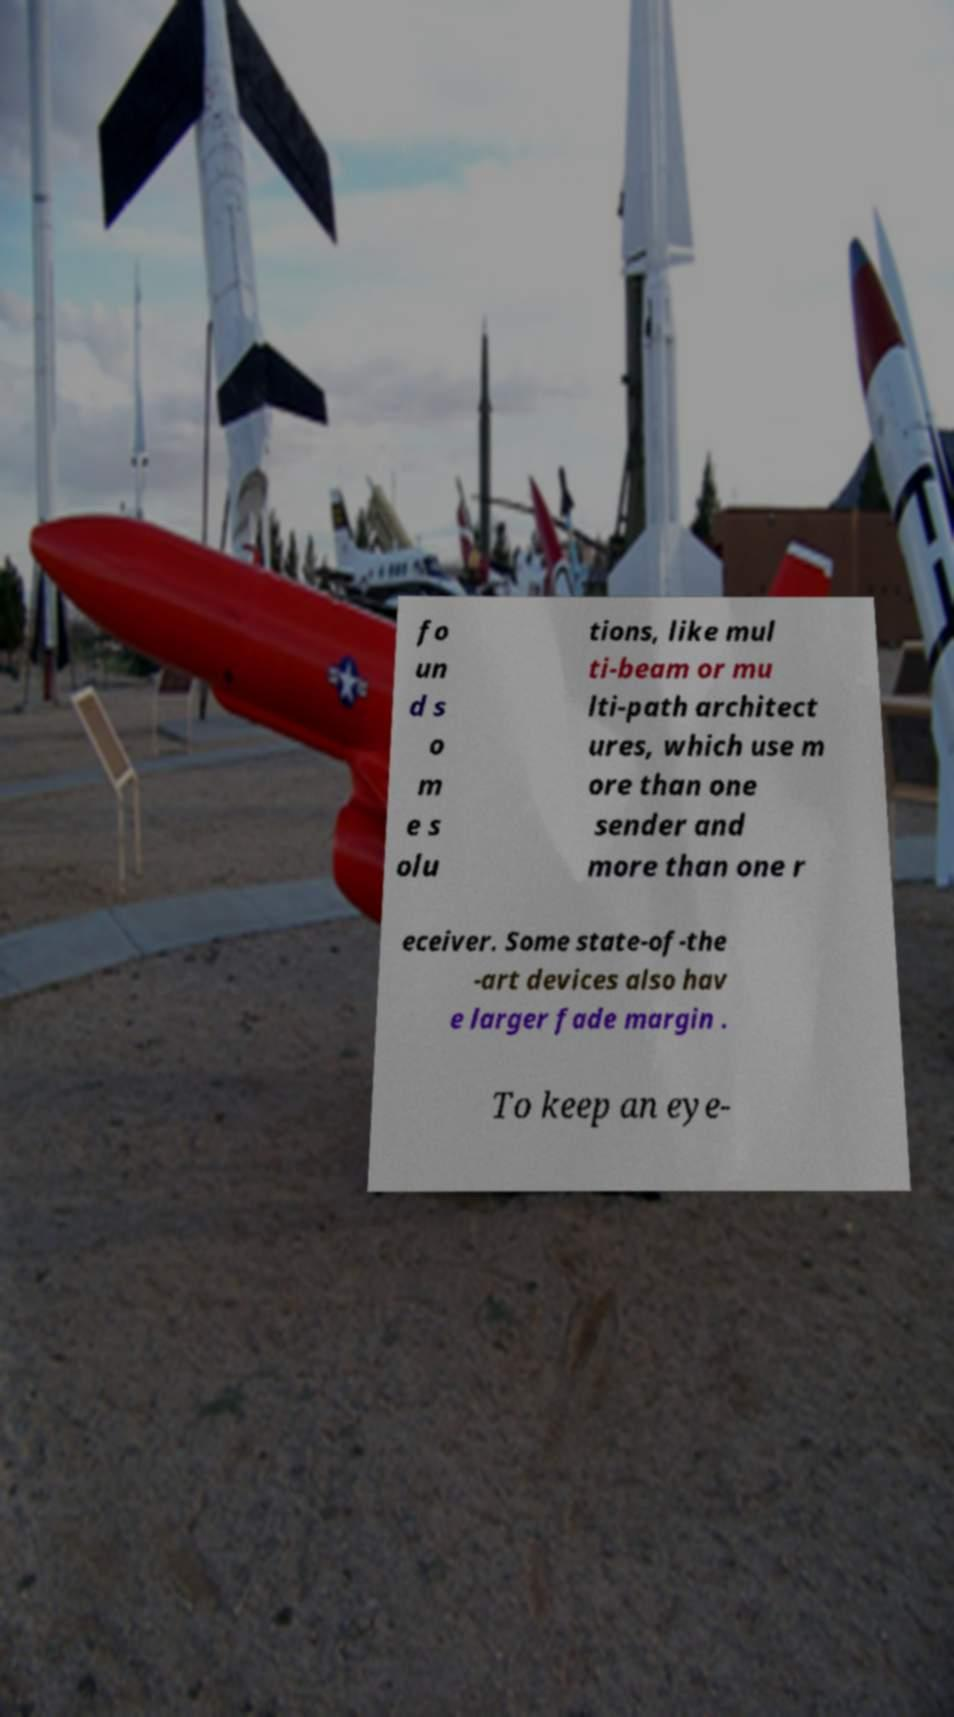Can you read and provide the text displayed in the image?This photo seems to have some interesting text. Can you extract and type it out for me? fo un d s o m e s olu tions, like mul ti-beam or mu lti-path architect ures, which use m ore than one sender and more than one r eceiver. Some state-of-the -art devices also hav e larger fade margin . To keep an eye- 